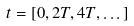Convert formula to latex. <formula><loc_0><loc_0><loc_500><loc_500>t = [ 0 , 2 T , 4 T , \dots ]</formula> 